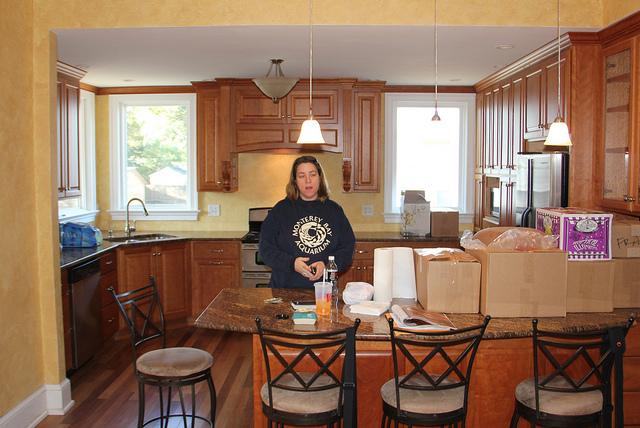How many chairs are seated around the bar top?
Be succinct. 4. Does the girl look like she is talking to someone?
Quick response, please. Yes. What room of the house is she in?
Keep it brief. Kitchen. 